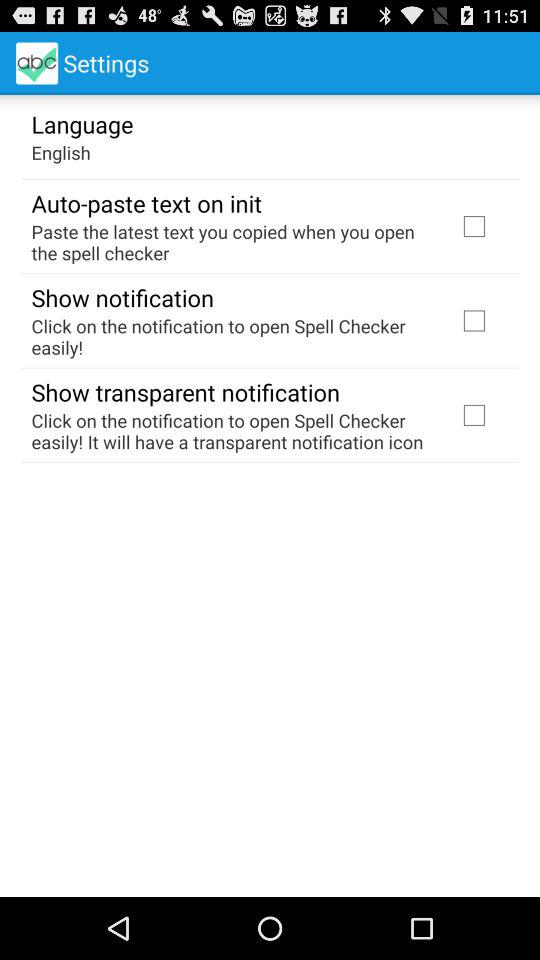What is the current status of the "Auto-paste text on init"? The status is "off". 